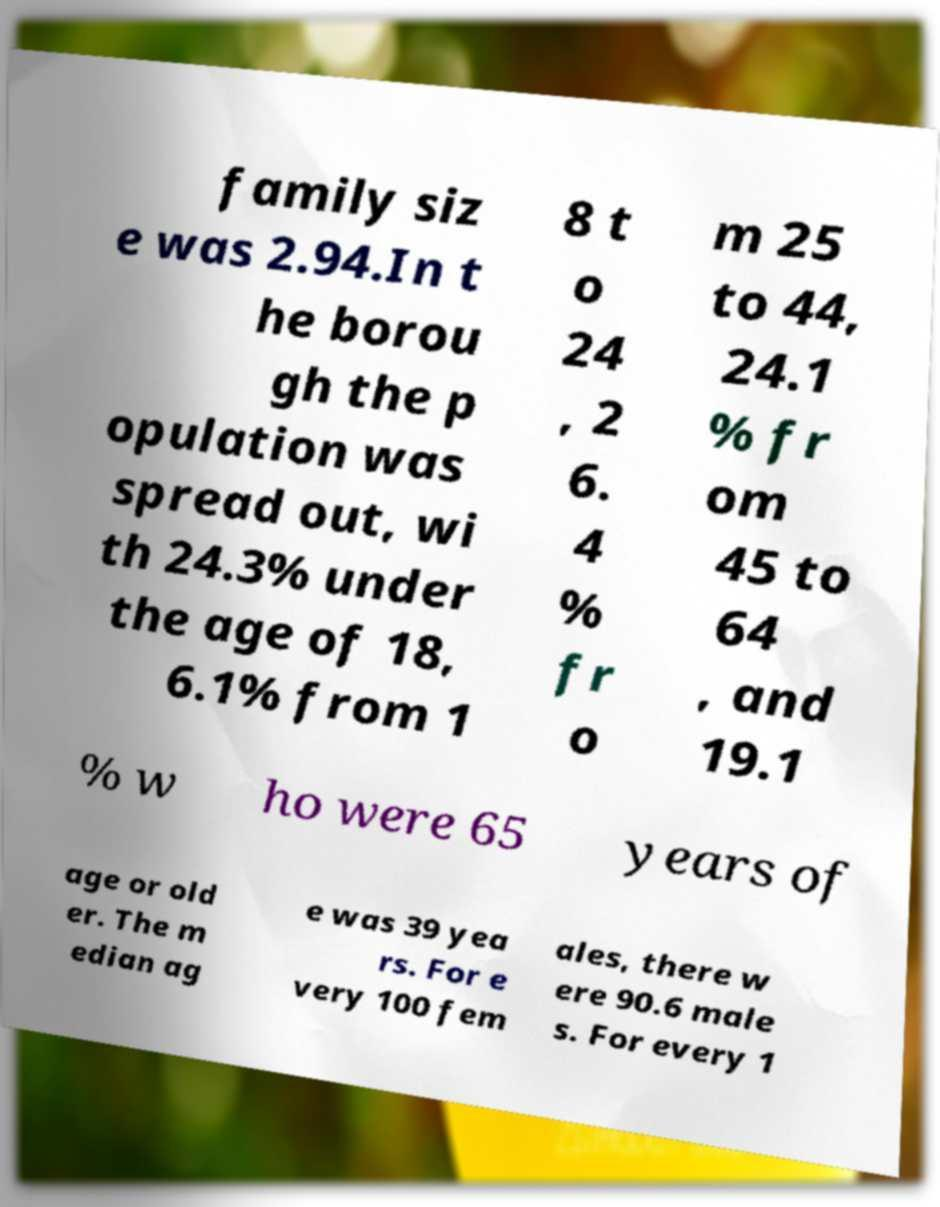Can you accurately transcribe the text from the provided image for me? family siz e was 2.94.In t he borou gh the p opulation was spread out, wi th 24.3% under the age of 18, 6.1% from 1 8 t o 24 , 2 6. 4 % fr o m 25 to 44, 24.1 % fr om 45 to 64 , and 19.1 % w ho were 65 years of age or old er. The m edian ag e was 39 yea rs. For e very 100 fem ales, there w ere 90.6 male s. For every 1 